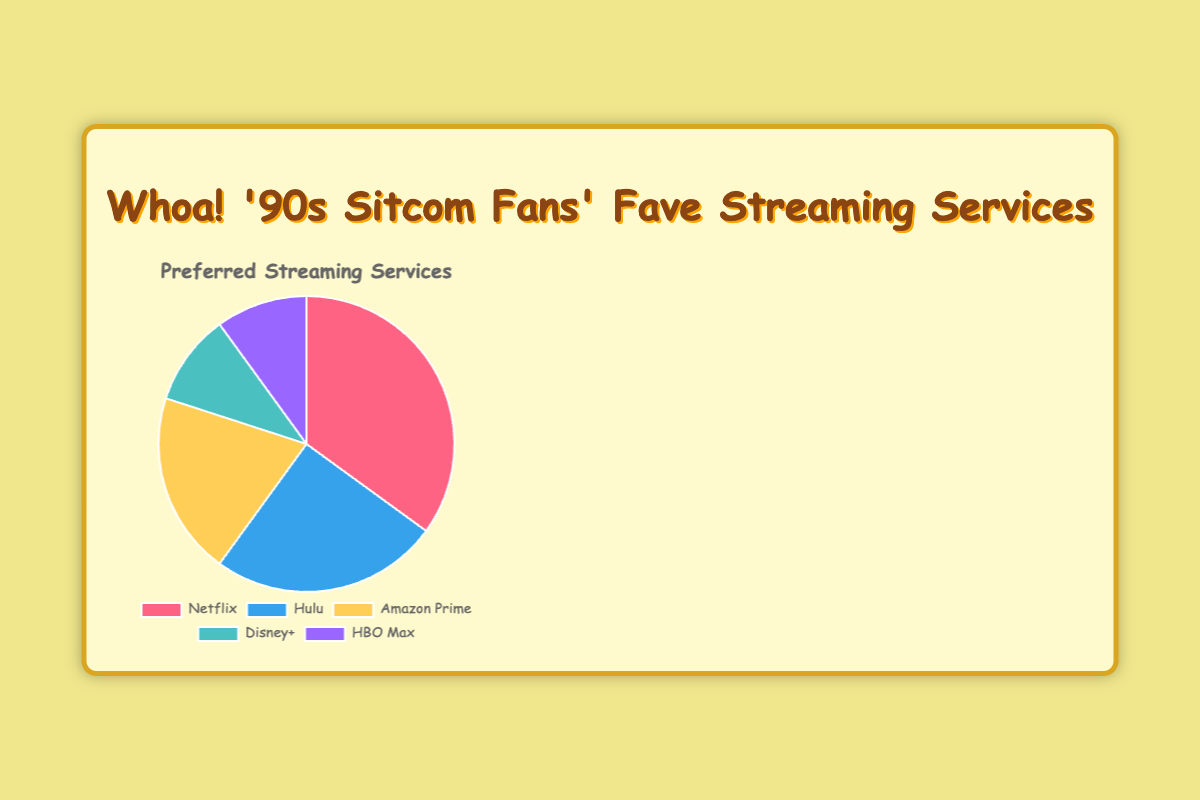What is the most preferred streaming service among '90s sitcom fans? The pie chart shows the percentage distribution of each streaming service. Netflix has the largest percentage slice.
Answer: Netflix Which two streaming services are equally preferred among '90s sitcom fans? Looking at the pie chart, both Disney+ and HBO Max have the same-sized slices, each representing 10%.
Answer: Disney+ and HBO Max How many more '90s sitcom fans prefer Netflix over Hulu? The pie chart shows that 35% prefer Netflix and 25% prefer Hulu. The difference is 35% - 25% = 10%.
Answer: 10% What is the combined preference percentage for Amazon Prime and Disney+? According to the pie chart, 20% of fans prefer Amazon Prime and 10% prefer Disney+. The combined percentage is 20% + 10% = 30%.
Answer: 30% Which streaming service has a preference percentage that is double that of Disney+? The pie chart shows that Disney+ has a 10% preference. Hulu has a 25% preference and Amazon Prime has a 20% preference; neither is double Disney+'s percentage. Netflix, however, has a 35% preference, which is more than double Disney+'s 10%.
Answer: Netflix How does the preference for Hulu compare to that for Amazon Prime? From the pie chart, Hulu has a 25% preference while Amazon Prime has a 20% preference. Therefore, Hulu is preferred by 5% more fans than Amazon Prime.
Answer: Hulu is preferred by 5% more Which streaming service has the smallest preferred percentage and what color represents it on the chart? Both Disney+ and HBO Max have the smallest preference with 10% each. The color for Disney+ is aqua, and for HBO Max, it is purple.
Answer: Disney+ in aqua and HBO Max in purple If you combine the preferences of Hulu and Amazon Prime, how does the total compare with Netflix? Hulu has 25% and Amazon Prime has 20%, combining these gives 25% + 20% = 45%. Comparing this to Netflix's 35%, Hulu and Amazon Prime together have a higher preference by 45% - 35% = 10%.
Answer: Hulu and Amazon Prime together are preferred by 10% more What is the average preference percentage of all five streaming services? Sum the preference percentages of all the streaming services: 35% (Netflix) + 25% (Hulu) + 20% (Amazon Prime) + 10% (Disney+) + 10% (HBO Max) = 100%. Divide by the number of services, which is 5. So, the average is 100% / 5 = 20%.
Answer: 20% 